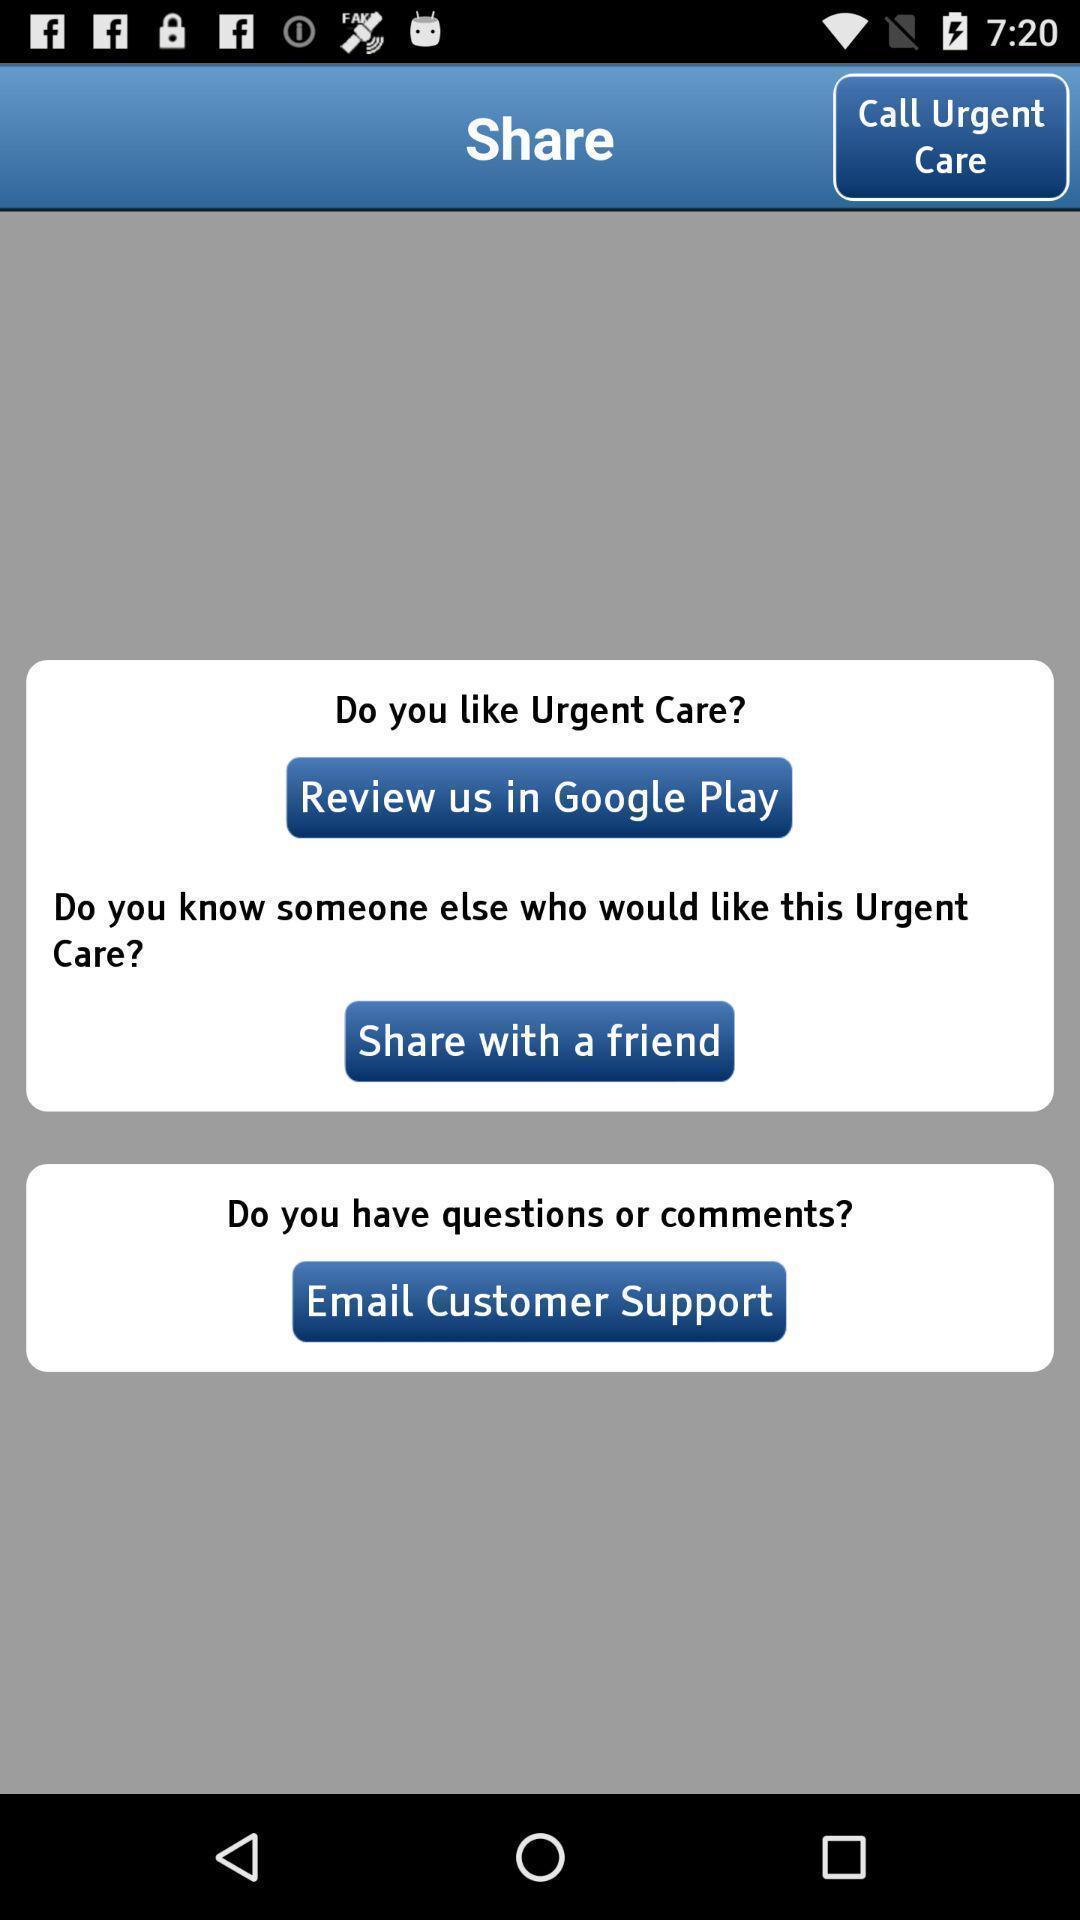Please provide a description for this image. Screen displaying multiple options about the application. 